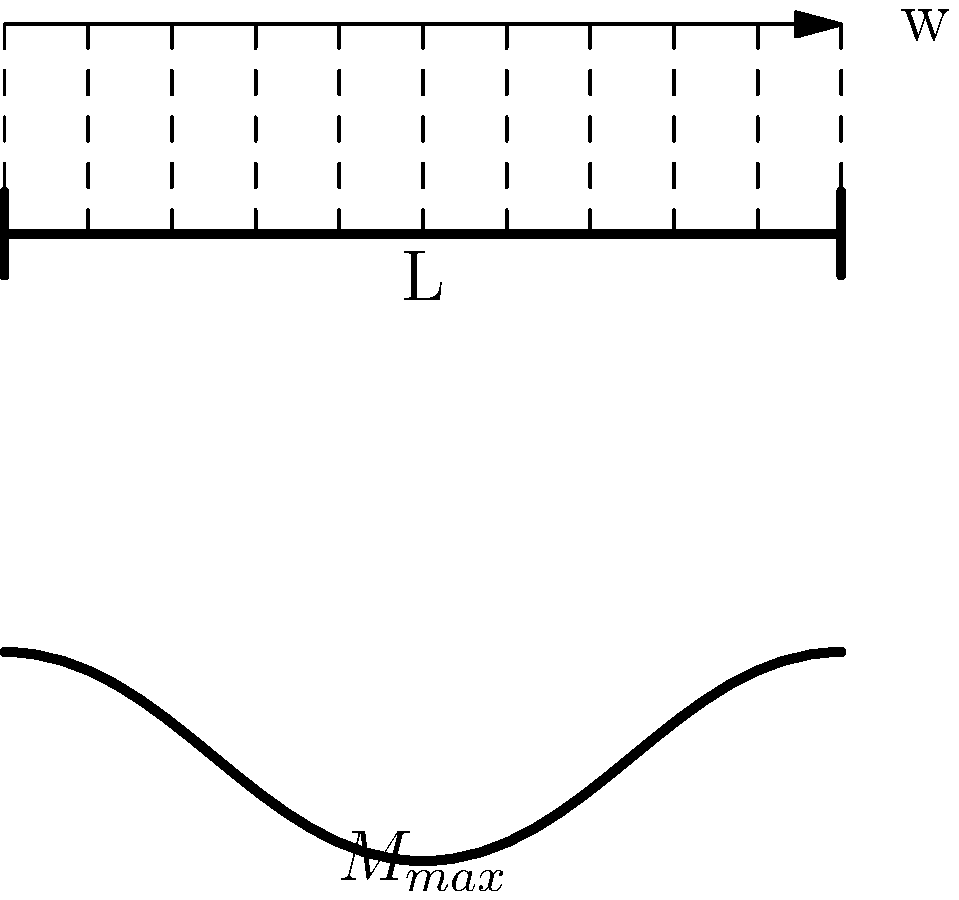In a network equipment installation project, you need to assess the structural integrity of a support beam for a server rack. The beam is simply supported and subject to a uniformly distributed load from the weight of the equipment. If the beam has a length L and is subjected to a uniformly distributed load w, what is the maximum bending moment (M_max) in the beam, and where does it occur? To find the maximum bending moment for a simply supported beam with a uniformly distributed load, we can follow these steps:

1. Identify the beam configuration:
   - Simply supported beam
   - Length: L
   - Uniformly distributed load: w (force per unit length)

2. Calculate the total load on the beam:
   Total load = w * L

3. Determine the reaction forces at the supports:
   Due to symmetry, each support bears half of the total load.
   Reaction force at each support = (w * L) / 2

4. Analyze the bending moment distribution:
   - The bending moment varies along the length of the beam
   - It is zero at the supports and maximum at the center

5. Calculate the maximum bending moment:
   The maximum bending moment occurs at the center of the beam (x = L/2)
   $$M_{max} = \frac{wL^2}{8}$$

6. Determine the location of the maximum bending moment:
   The maximum bending moment occurs at the midpoint of the beam, x = L/2

The bending moment diagram for this case is parabolic, with the vertex at the center of the beam, representing the maximum bending moment.
Answer: $M_{max} = \frac{wL^2}{8}$ at x = L/2 